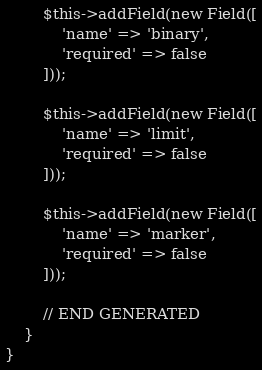<code> <loc_0><loc_0><loc_500><loc_500><_PHP_>        $this->addField(new Field([
            'name' => 'binary',
            'required' => false
        ]));

        $this->addField(new Field([
            'name' => 'limit',
            'required' => false
        ]));

        $this->addField(new Field([
            'name' => 'marker',
            'required' => false
        ]));

        // END GENERATED
    }
}
</code> 